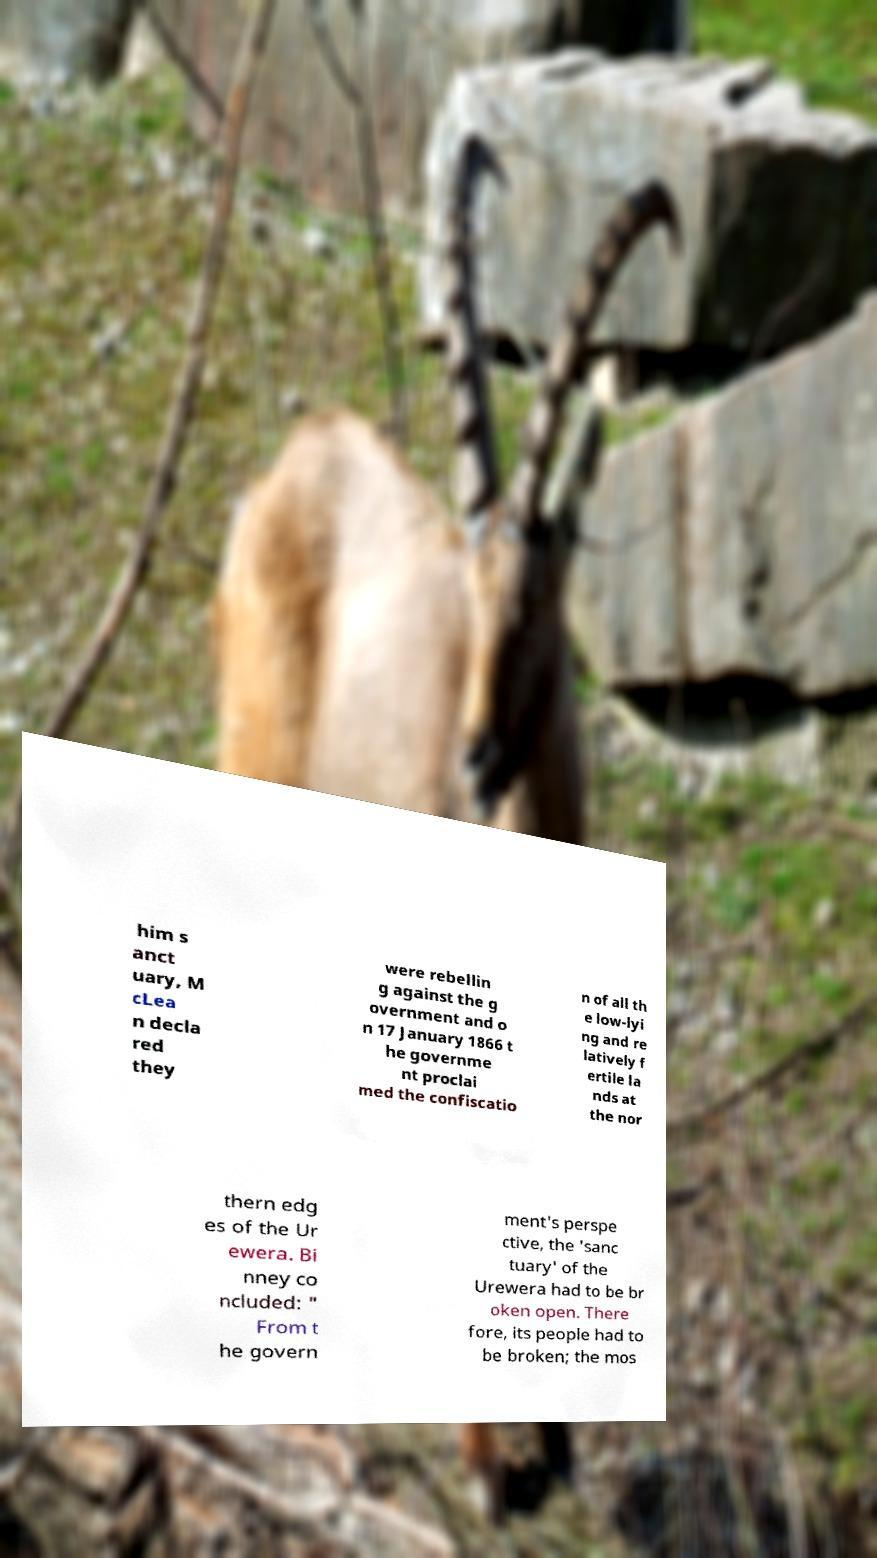Please read and relay the text visible in this image. What does it say? him s anct uary, M cLea n decla red they were rebellin g against the g overnment and o n 17 January 1866 t he governme nt proclai med the confiscatio n of all th e low-lyi ng and re latively f ertile la nds at the nor thern edg es of the Ur ewera. Bi nney co ncluded: " From t he govern ment's perspe ctive, the 'sanc tuary' of the Urewera had to be br oken open. There fore, its people had to be broken; the mos 